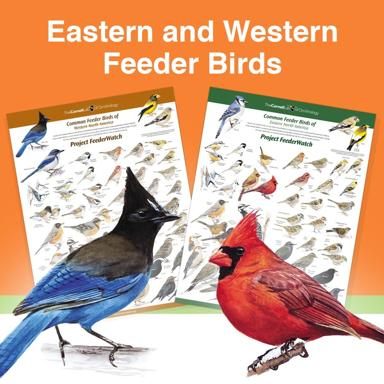How can I differentiate between Eastern and Western feeder birds? To effectively differentiate between Eastern and Western feeder birds, you can observe several key aspects: coloration, size, shape, and behavioral patterns. For instance, Eastern birds might show different plumage patterns compared to their Western counterparts. Consider noting specific traits such as the wing bars, tail length, and the color intensity, which are often region-specific due to environmental adaptations. Observing these nuances helps in precise identification and understanding how these birds have evolved distinctly in separate geographical locales. 